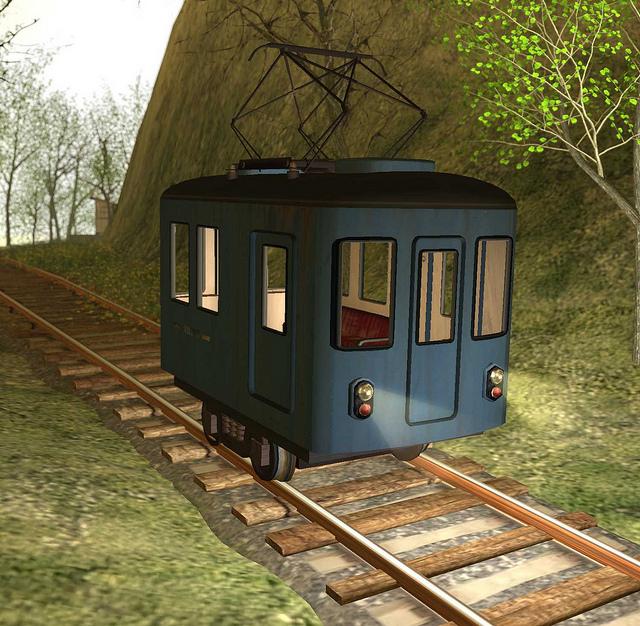How many seats can you see?
Write a very short answer. 1. Is this a full train?
Keep it brief. No. Are there any passengers on the train?
Answer briefly. No. 